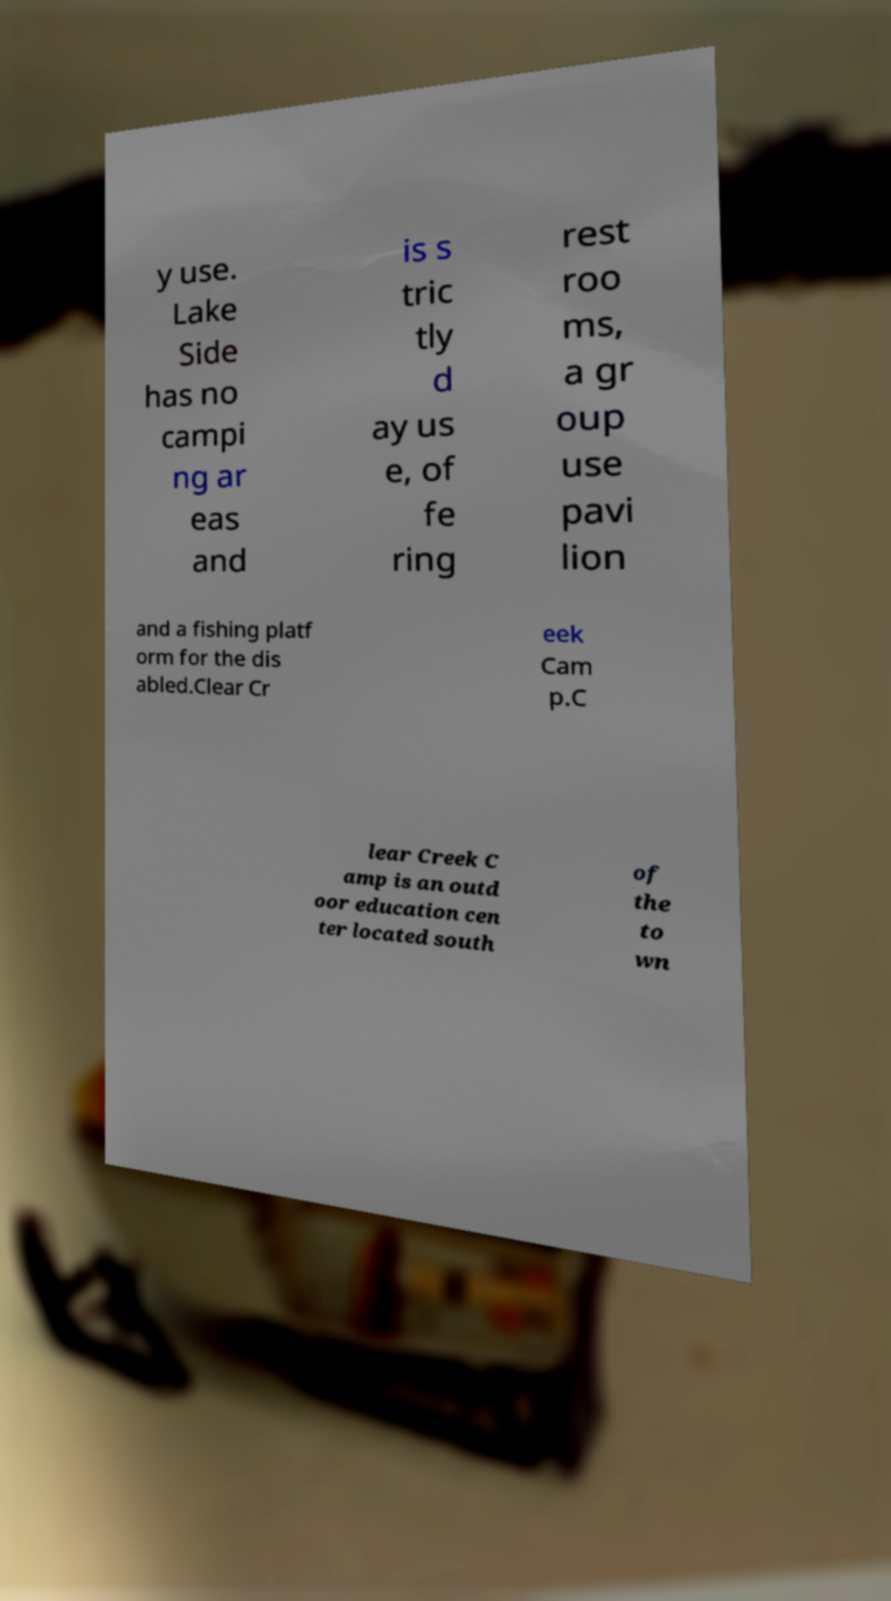Can you accurately transcribe the text from the provided image for me? y use. Lake Side has no campi ng ar eas and is s tric tly d ay us e, of fe ring rest roo ms, a gr oup use pavi lion and a fishing platf orm for the dis abled.Clear Cr eek Cam p.C lear Creek C amp is an outd oor education cen ter located south of the to wn 